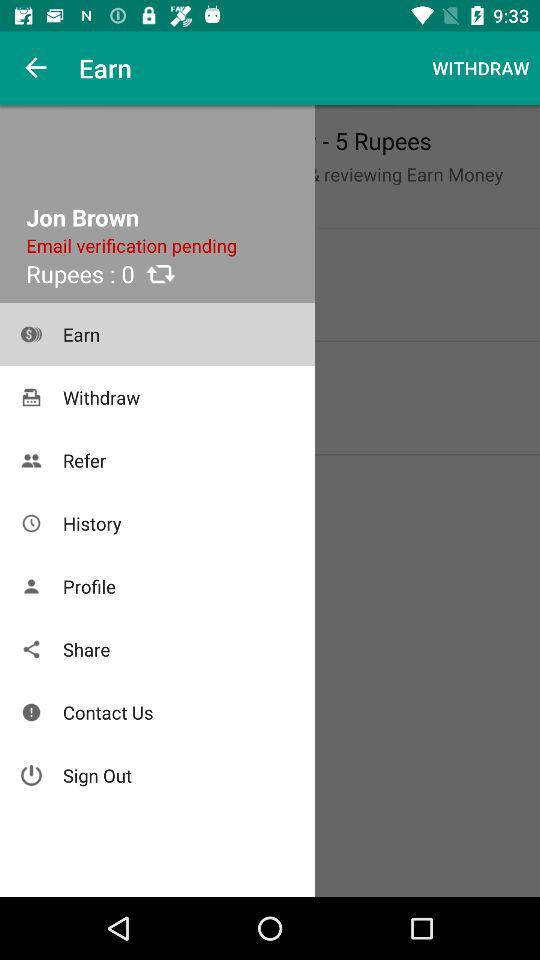What is pending for verification? There is an email pending for verification. 